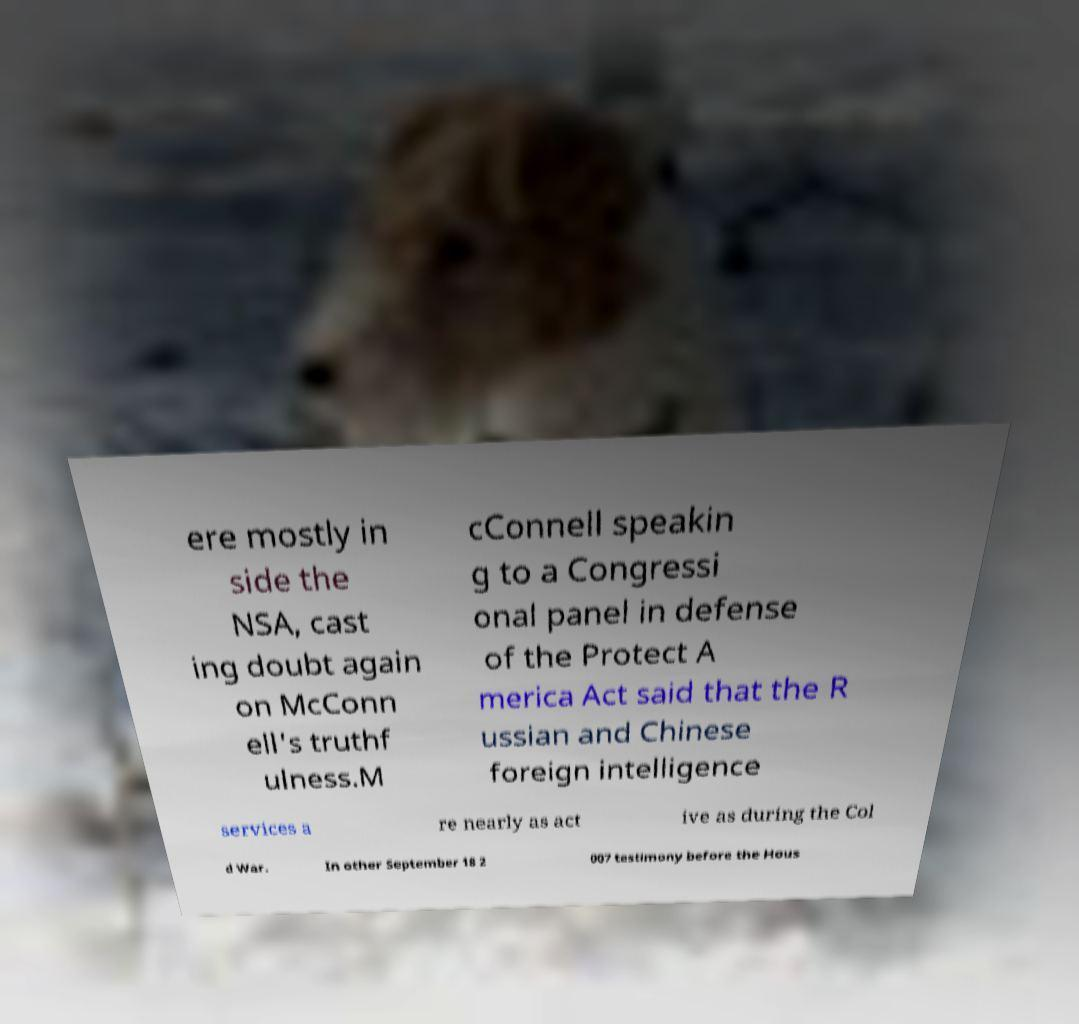Could you assist in decoding the text presented in this image and type it out clearly? ere mostly in side the NSA, cast ing doubt again on McConn ell's truthf ulness.M cConnell speakin g to a Congressi onal panel in defense of the Protect A merica Act said that the R ussian and Chinese foreign intelligence services a re nearly as act ive as during the Col d War. In other September 18 2 007 testimony before the Hous 